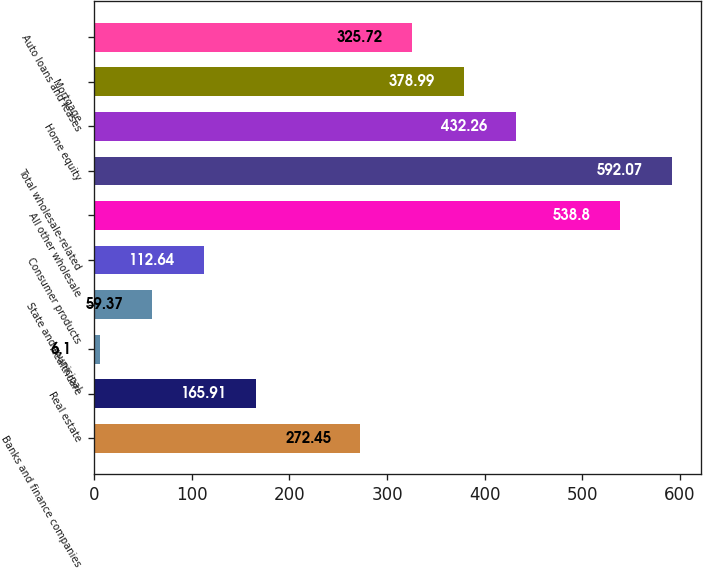Convert chart. <chart><loc_0><loc_0><loc_500><loc_500><bar_chart><fcel>Banks and finance companies<fcel>Real estate<fcel>Healthcare<fcel>State and municipal<fcel>Consumer products<fcel>All other wholesale<fcel>Total wholesale-related<fcel>Home equity<fcel>Mortgage<fcel>Auto loans and leases<nl><fcel>272.45<fcel>165.91<fcel>6.1<fcel>59.37<fcel>112.64<fcel>538.8<fcel>592.07<fcel>432.26<fcel>378.99<fcel>325.72<nl></chart> 